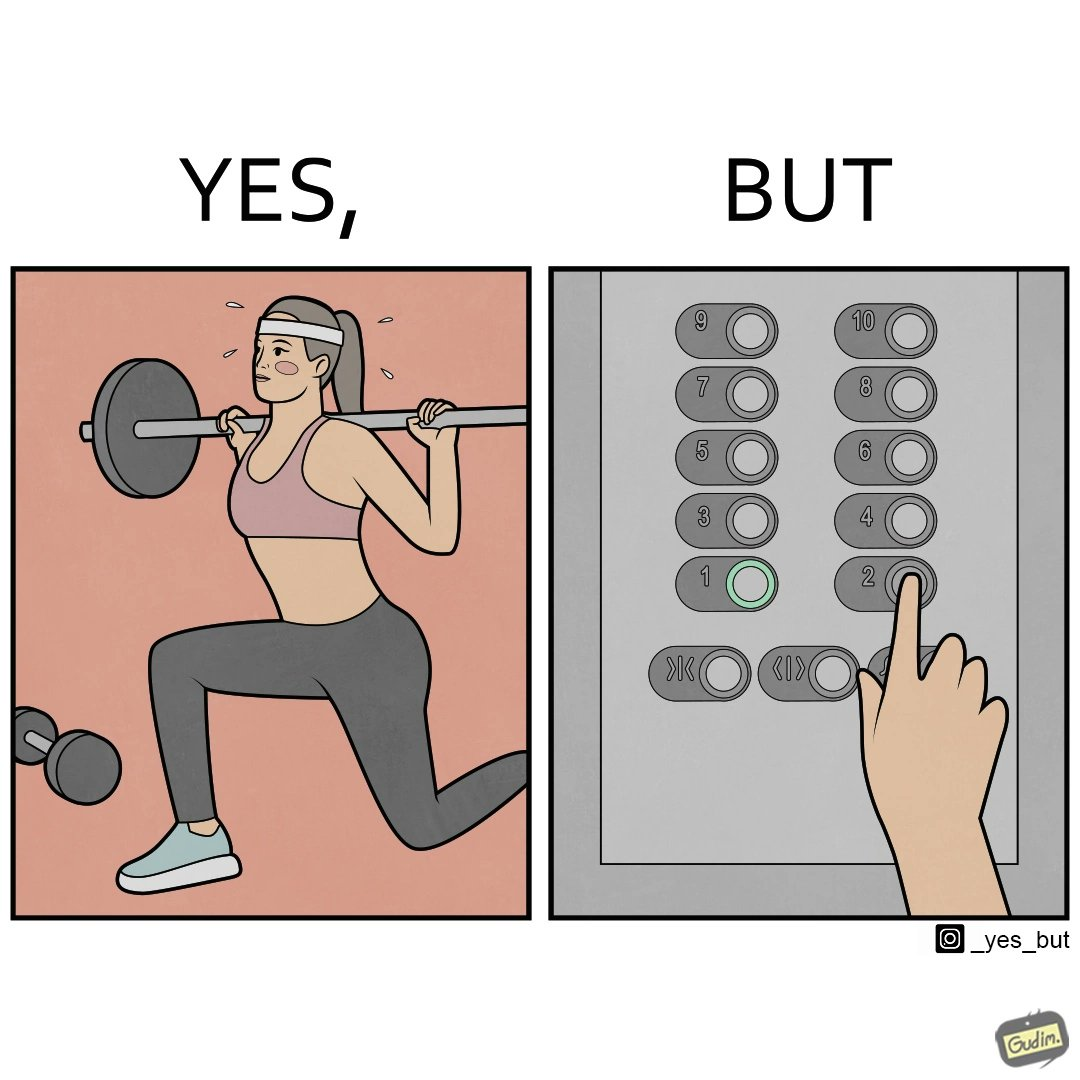Describe what you see in the left and right parts of this image. In the left part of the image: The image shows a women exercising with a bar bell in a gym. She is wearing a sport outfit. She is crouching down on one leg doing a single leg squat with a bar bell. In the right part of the image: The image shows the control panel inside of an elevator. The indicator for the first floor is green which means the button for the first floor was pressed. A hand is about to press the button for the second floor. 